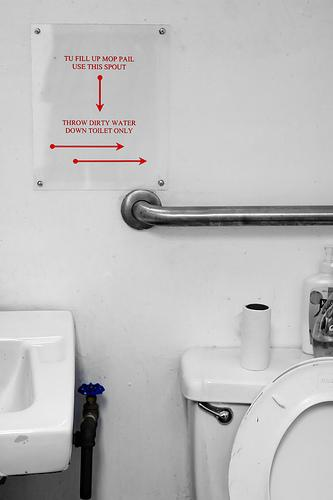State an object in the image that is not related to the toilet. A set of instructions written in red is present in the image. How is the bolt in the image being used? The bolt is holding up a sign. Describe the position and state of the toilet seat in the image. The toilet seat is left up, exposing the toilet bowl. Identify the color of the handle on the water faucet. The handle on the water faucet is blue. Mention an object in the image that may need repair or replacement. The paint is chipping, which may need repair or replacement. What may be the purpose of the safety bar in the image? The silver safety bar is meant to provide support and stability while using the toilet. What is the placement of the toilet paper roll in the image? The toilet paper roll is on top of the toilet. Point out the object that can be used for hand hygiene in the image. A soap bottle with a pump is present for hand hygiene. In terms of color, describe any two objects in the image. There is a blue handle for the water faucet and a silver colored toilet flusher. What is the color and direction of the arrow? The arrow is red and pointing downward. 